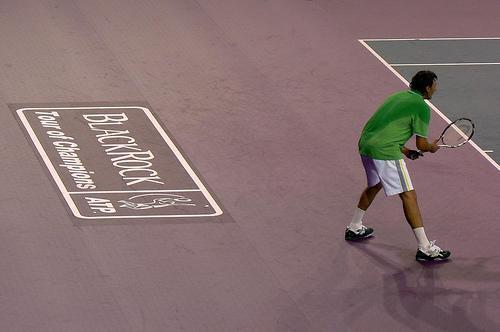How many players can be seen?
Give a very brief answer. 1. How many tennis rackets are in the picture?
Give a very brief answer. 1. 